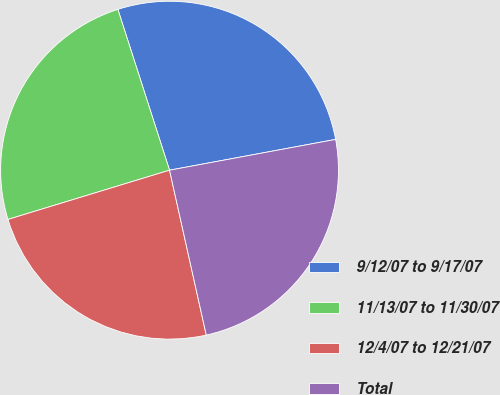Convert chart to OTSL. <chart><loc_0><loc_0><loc_500><loc_500><pie_chart><fcel>9/12/07 to 9/17/07<fcel>11/13/07 to 11/30/07<fcel>12/4/07 to 12/21/07<fcel>Total<nl><fcel>27.03%<fcel>24.76%<fcel>23.78%<fcel>24.43%<nl></chart> 